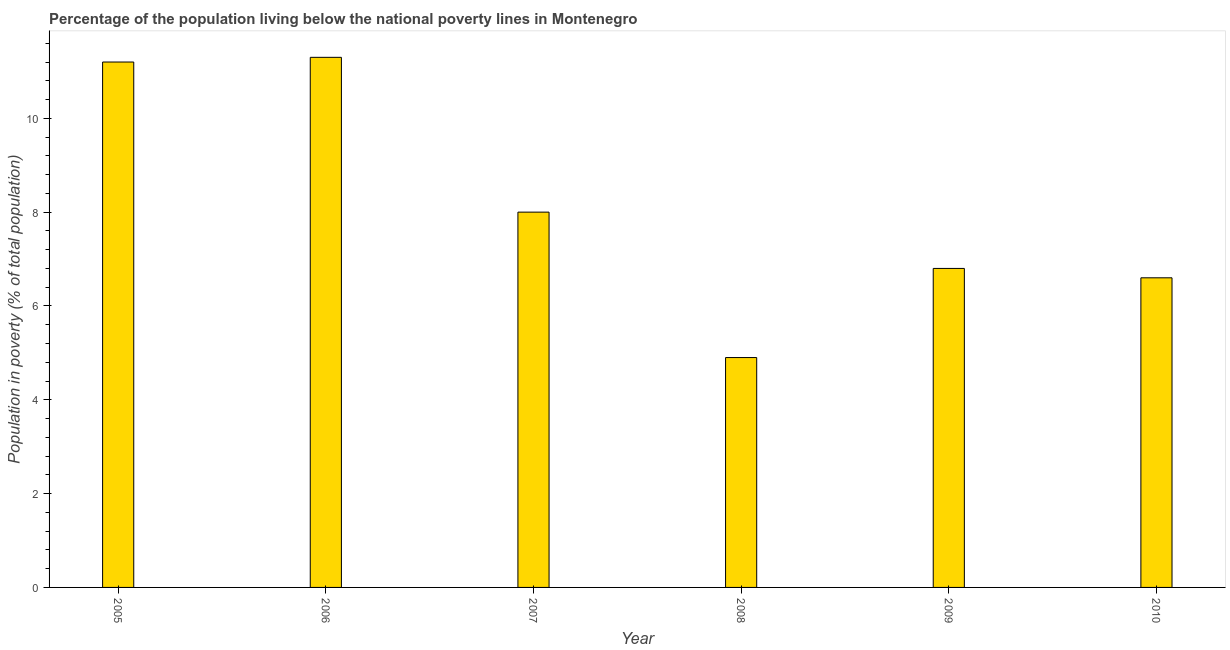What is the title of the graph?
Offer a very short reply. Percentage of the population living below the national poverty lines in Montenegro. What is the label or title of the X-axis?
Your answer should be very brief. Year. What is the label or title of the Y-axis?
Offer a very short reply. Population in poverty (% of total population). What is the percentage of population living below poverty line in 2007?
Keep it short and to the point. 8. Across all years, what is the minimum percentage of population living below poverty line?
Your answer should be very brief. 4.9. In which year was the percentage of population living below poverty line minimum?
Ensure brevity in your answer.  2008. What is the sum of the percentage of population living below poverty line?
Make the answer very short. 48.8. What is the average percentage of population living below poverty line per year?
Give a very brief answer. 8.13. What is the median percentage of population living below poverty line?
Provide a short and direct response. 7.4. What is the ratio of the percentage of population living below poverty line in 2006 to that in 2007?
Offer a very short reply. 1.41. Is the percentage of population living below poverty line in 2009 less than that in 2010?
Offer a very short reply. No. Is the sum of the percentage of population living below poverty line in 2006 and 2007 greater than the maximum percentage of population living below poverty line across all years?
Your response must be concise. Yes. What is the difference between the highest and the lowest percentage of population living below poverty line?
Your answer should be compact. 6.4. In how many years, is the percentage of population living below poverty line greater than the average percentage of population living below poverty line taken over all years?
Ensure brevity in your answer.  2. Are all the bars in the graph horizontal?
Give a very brief answer. No. How many years are there in the graph?
Your response must be concise. 6. Are the values on the major ticks of Y-axis written in scientific E-notation?
Provide a short and direct response. No. What is the Population in poverty (% of total population) in 2005?
Keep it short and to the point. 11.2. What is the Population in poverty (% of total population) in 2008?
Offer a terse response. 4.9. What is the Population in poverty (% of total population) in 2009?
Offer a terse response. 6.8. What is the difference between the Population in poverty (% of total population) in 2005 and 2006?
Offer a very short reply. -0.1. What is the difference between the Population in poverty (% of total population) in 2005 and 2007?
Keep it short and to the point. 3.2. What is the difference between the Population in poverty (% of total population) in 2005 and 2010?
Your answer should be compact. 4.6. What is the difference between the Population in poverty (% of total population) in 2007 and 2009?
Give a very brief answer. 1.2. What is the difference between the Population in poverty (% of total population) in 2007 and 2010?
Your answer should be very brief. 1.4. What is the difference between the Population in poverty (% of total population) in 2009 and 2010?
Offer a terse response. 0.2. What is the ratio of the Population in poverty (% of total population) in 2005 to that in 2008?
Provide a succinct answer. 2.29. What is the ratio of the Population in poverty (% of total population) in 2005 to that in 2009?
Ensure brevity in your answer.  1.65. What is the ratio of the Population in poverty (% of total population) in 2005 to that in 2010?
Your response must be concise. 1.7. What is the ratio of the Population in poverty (% of total population) in 2006 to that in 2007?
Provide a short and direct response. 1.41. What is the ratio of the Population in poverty (% of total population) in 2006 to that in 2008?
Offer a terse response. 2.31. What is the ratio of the Population in poverty (% of total population) in 2006 to that in 2009?
Give a very brief answer. 1.66. What is the ratio of the Population in poverty (% of total population) in 2006 to that in 2010?
Offer a terse response. 1.71. What is the ratio of the Population in poverty (% of total population) in 2007 to that in 2008?
Provide a succinct answer. 1.63. What is the ratio of the Population in poverty (% of total population) in 2007 to that in 2009?
Provide a short and direct response. 1.18. What is the ratio of the Population in poverty (% of total population) in 2007 to that in 2010?
Provide a succinct answer. 1.21. What is the ratio of the Population in poverty (% of total population) in 2008 to that in 2009?
Ensure brevity in your answer.  0.72. What is the ratio of the Population in poverty (% of total population) in 2008 to that in 2010?
Ensure brevity in your answer.  0.74. What is the ratio of the Population in poverty (% of total population) in 2009 to that in 2010?
Ensure brevity in your answer.  1.03. 